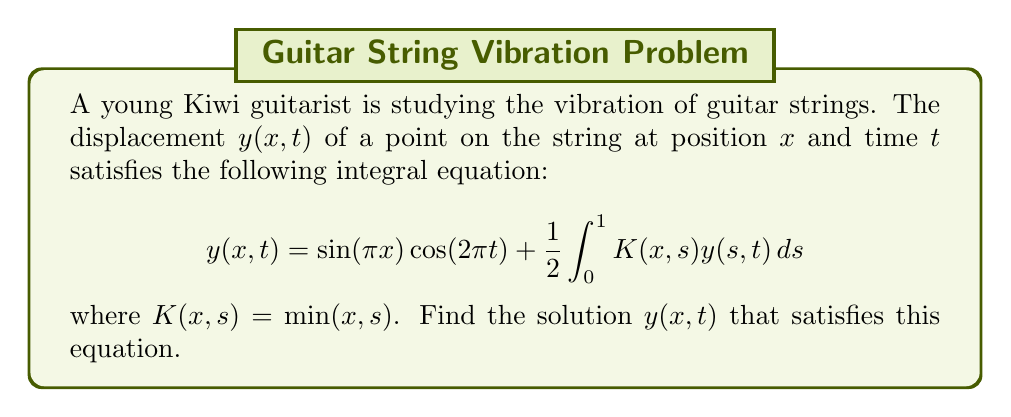Could you help me with this problem? Let's solve this step-by-step:

1) First, we assume that the solution has the form:
   $$y(x,t) = A\sin(\pi x)\cos(2\pi t)$$
   where $A$ is a constant we need to determine.

2) Substitute this into the integral equation:
   $$A\sin(\pi x)\cos(2\pi t) = \sin(\pi x)\cos(2\pi t) + \frac{1}{2}\int_0^1 \min(x,s)A\sin(\pi s)\cos(2\pi t)ds$$

3) The $\cos(2\pi t)$ term is common to both sides, so we can cancel it out:
   $$A\sin(\pi x) = \sin(\pi x) + \frac{A}{2}\int_0^1 \min(x,s)\sin(\pi s)ds$$

4) Now, let's evaluate the integral:
   $$\int_0^1 \min(x,s)\sin(\pi s)ds = \int_0^x s\sin(\pi s)ds + x\int_x^1 \sin(\pi s)ds$$

5) Solving these integrals:
   $$= \left[-\frac{s}{\pi}\cos(\pi s) + \frac{1}{\pi^2}\sin(\pi s)\right]_0^x - \frac{x}{\pi}\left[\cos(\pi s)\right]_x^1$$
   $$= -\frac{x}{\pi}\cos(\pi x) + \frac{1}{\pi^2}\sin(\pi x) + \frac{x}{\pi}(\cos(\pi x) + 1)$$
   $$= \frac{1}{\pi^2}\sin(\pi x) + \frac{x}{\pi}$$

6) Substituting this back into the equation from step 3:
   $$A\sin(\pi x) = \sin(\pi x) + \frac{A}{2}\left(\frac{1}{\pi^2}\sin(\pi x) + \frac{x}{\pi}\right)$$

7) For this to be true for all $x$, we must have:
   $$A = 1 + \frac{A}{2\pi^2}$$

8) Solving for $A$:
   $$A - \frac{A}{2\pi^2} = 1$$
   $$A\left(1 - \frac{1}{2\pi^2}\right) = 1$$
   $$A = \frac{1}{1 - \frac{1}{2\pi^2}} = \frac{2\pi^2}{2\pi^2 - 1}$$

9) Therefore, the solution is:
   $$y(x,t) = \frac{2\pi^2}{2\pi^2 - 1}\sin(\pi x)\cos(2\pi t)$$
Answer: $y(x,t) = \frac{2\pi^2}{2\pi^2 - 1}\sin(\pi x)\cos(2\pi t)$ 